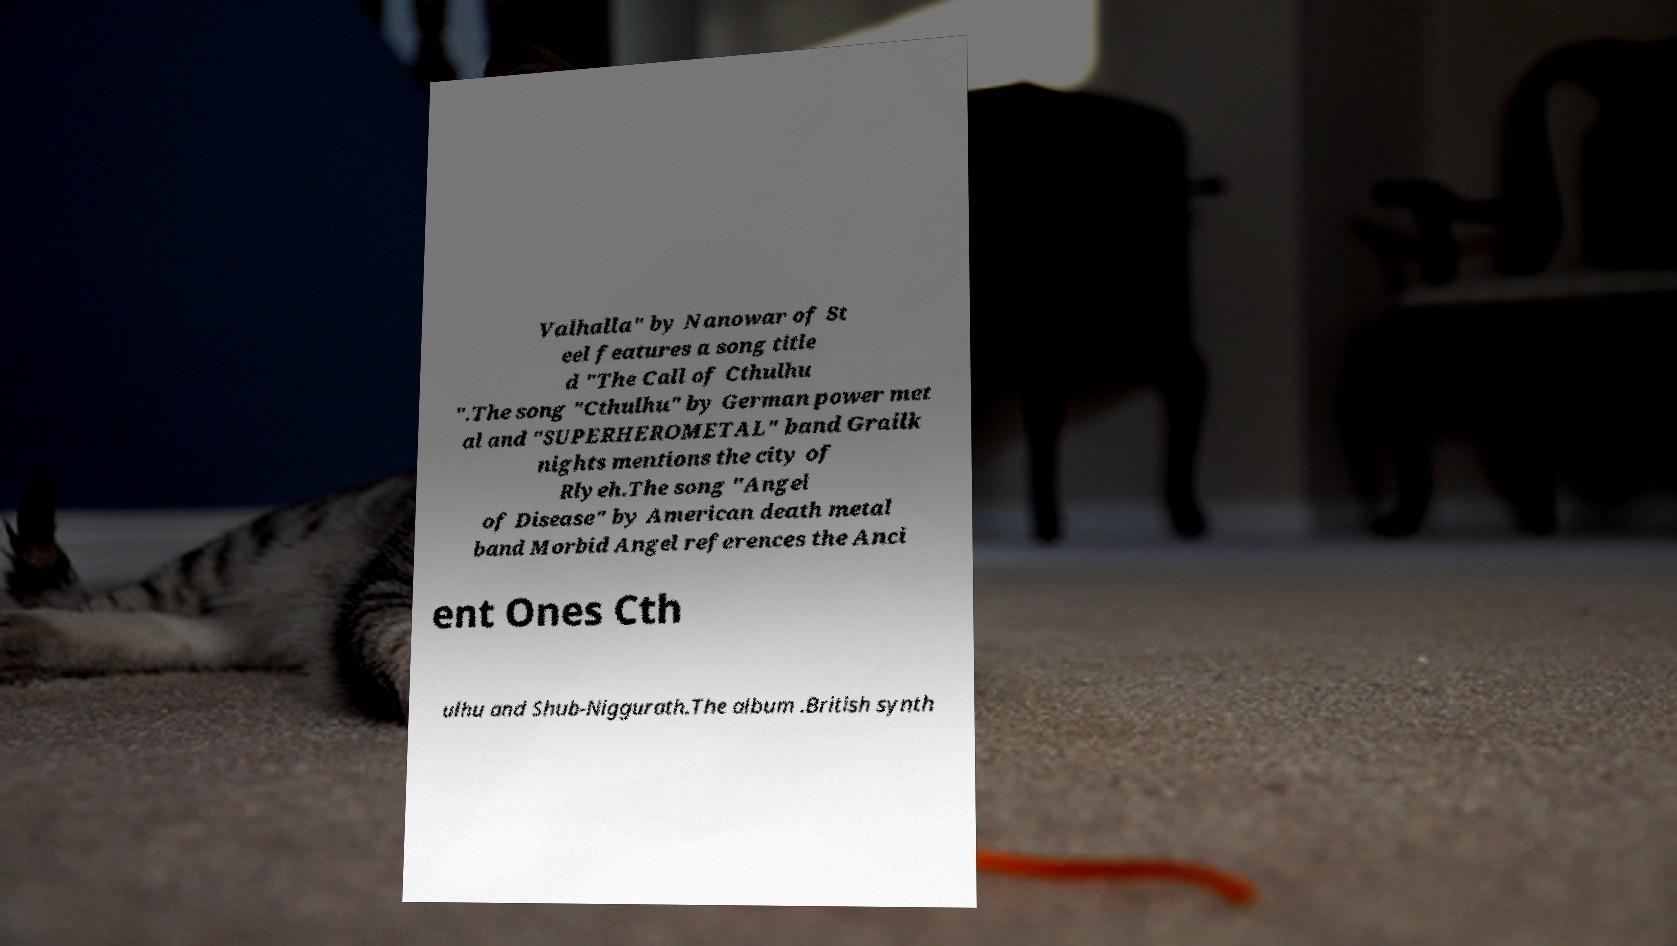Could you assist in decoding the text presented in this image and type it out clearly? Valhalla" by Nanowar of St eel features a song title d "The Call of Cthulhu ".The song "Cthulhu" by German power met al and "SUPERHEROMETAL" band Grailk nights mentions the city of Rlyeh.The song "Angel of Disease" by American death metal band Morbid Angel references the Anci ent Ones Cth ulhu and Shub-Niggurath.The album .British synth 